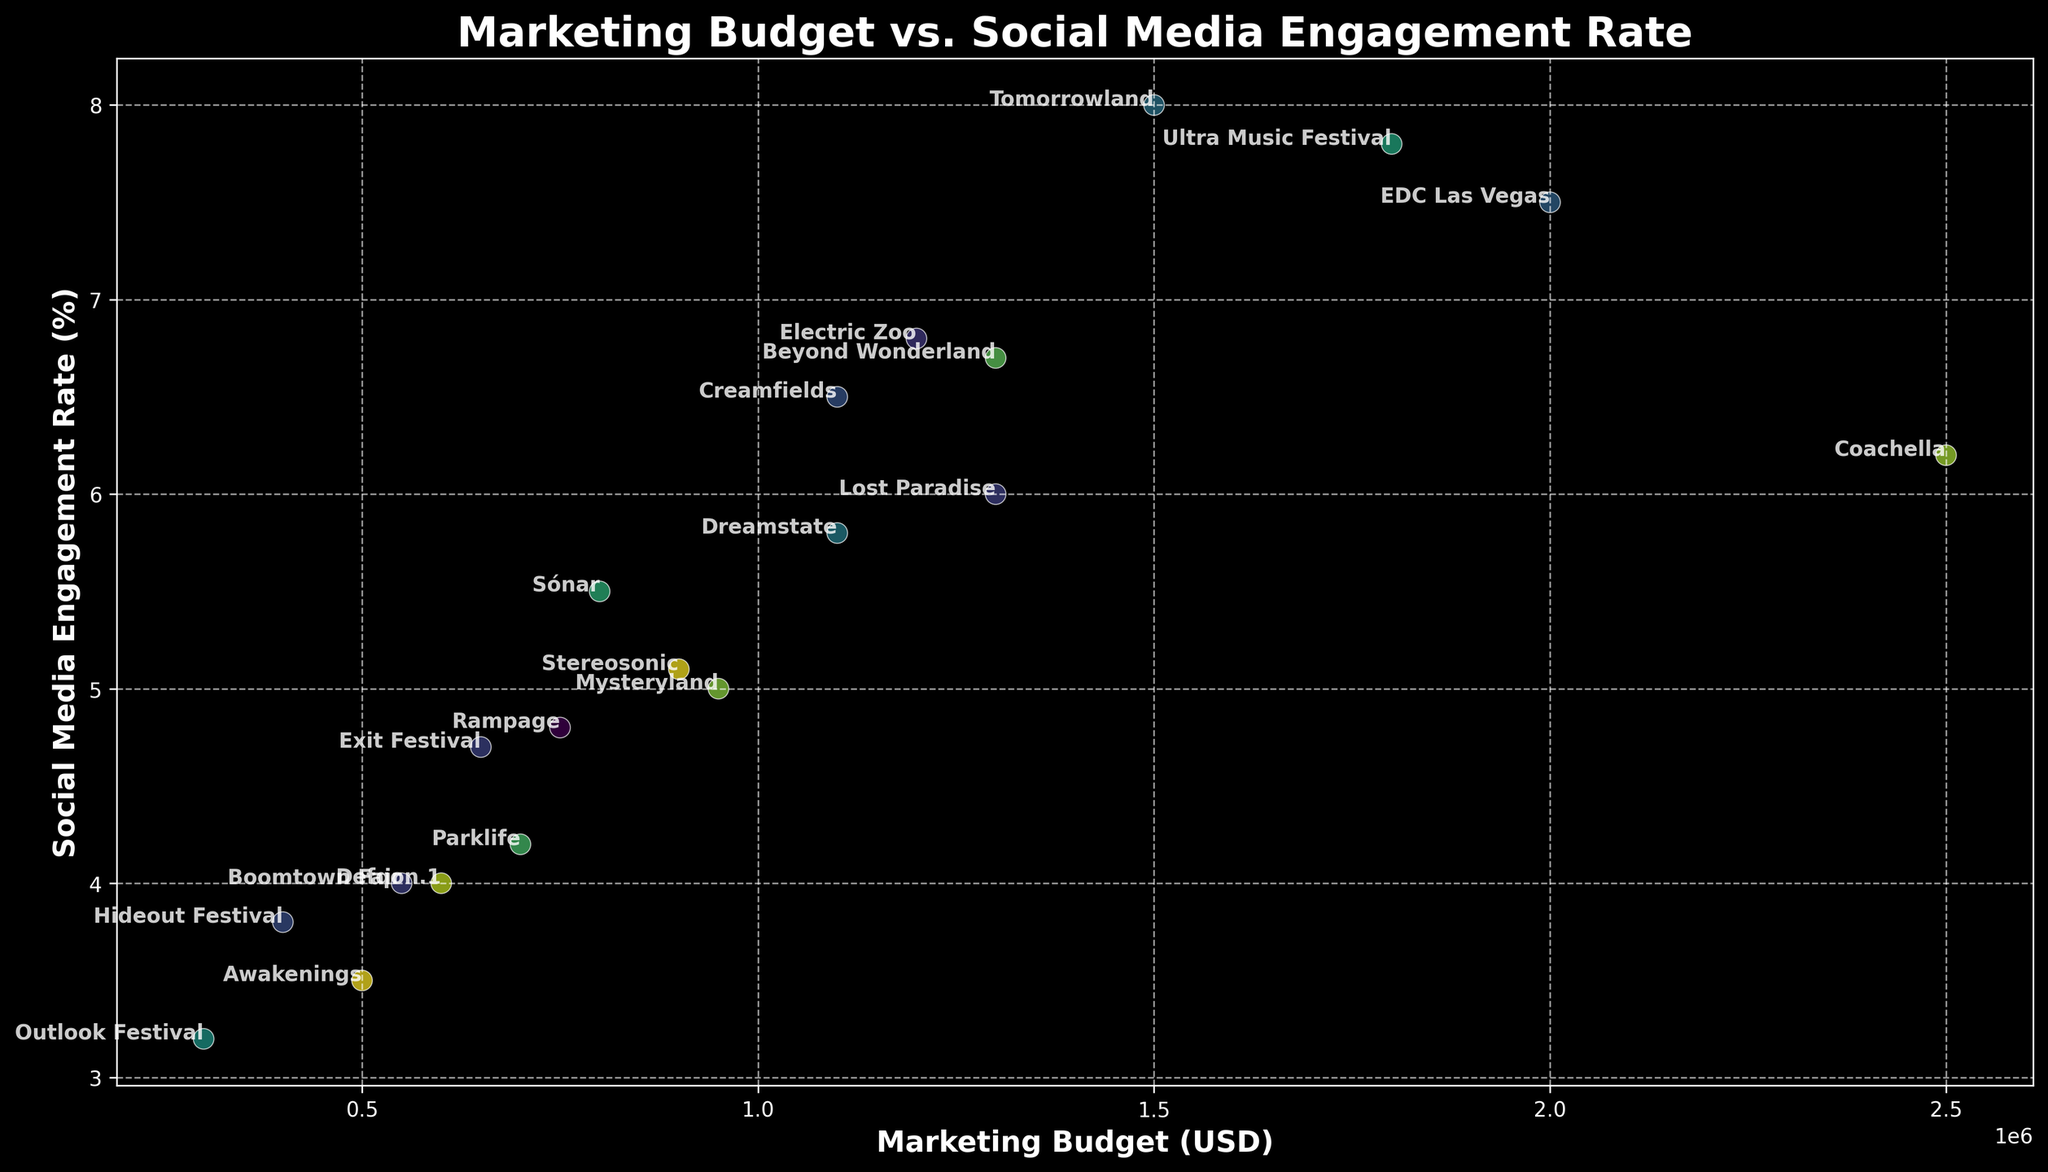What's the marketing budget of the festival with the highest engagement rate? First, identify the festival with the highest social media engagement rate, which is Tomorrowland at 8.0%. Then look for its marketing budget, which is $1,500,000.
Answer: $1,500,000 Which festival has the lowest social media engagement rate and what is its marketing budget? The festival with the lowest social media engagement rate is Outlook Festival at 3.2%. Its marketing budget is $300,000.
Answer: Outlook Festival, $300,000 What is the average social media engagement rate of festivals with a marketing budget above $1,000,000? Identify the festivals with marketing budgets above $1,000,000: EDC Las Vegas (7.5%), Tomorrowland (8.0%), Ultra Music Festival (7.8%), Coachella (6.2%), Electric Zoo (6.8%), Beyond Wonderland (6.7%), Lost Paradise (6.0%), Dreamstate (5.8%). Calculate their average engagement rate: (7.5 + 8.0 + 7.8 + 6.2 + 6.8 + 6.7 + 6.0 + 5.8) / 8 = 6.85%.
Answer: 6.85% How does Coachella's social media engagement rate compare to Dreamstate's? Look at the social media engagement rates for Coachella and Dreamstate. Coachella has a 6.2% rate, while Dreamstate has a 5.8% rate. Coachella's rate is higher.
Answer: Coachella's rate is higher Which festival is closest in color to Defqon.1 on the plot? Visually compare the color of Defqon.1 to other points. Possible candidates can be identified, and then the exact color match is determined. Assuming the closest color point is visually closest, which might vary slightly depending on the plot view.
Answer: [Provide accurate color comparison based on plot] What is the total marketing budget for all festivals with engagement rates above 5%? Identify festivals with engagement rates above 5%: EDC Las Vegas ($2,000,000), Tomorrowland ($1,500,000), Ultra Music Festival ($1,800,000), Coachella ($2,500,000), Creamfields ($1,100,000), Electric Zoo ($1,200,000), Beyond Wonderland ($1,300,000), Lost Paradise ($1,300,000), Dreamstate ($1,100,000), Stereosonic ($900,000). Sum their budgets: 2,000,000 + 1,500,000 + 1,800,000 + 2,500,000 + 1,100,000 + 1,200,000 + 1,300,000 + 1,300,000 + 1,100,000 + 900,000 = $14,700,000.
Answer: $14,700,000 Are there any festivals with the same engagement rate, and if so, which ones? Compare the engagement rates of all festivals visually or via list: Only Defqon.1 and Boomtown Fair both have a 4.0% engagement rate.
Answer: Defqon.1 and Boomtown Fair What is the difference in engagement rates between EDC Las Vegas and Parklife? EDC Las Vegas has an engagement rate of 7.5%, whereas Parklife has 4.2%. The difference is 7.5 - 4.2 = 3.3%.
Answer: 3.3% What is the median social media engagement rate for all festivals? List all engagement rates: [7.5, 8.0, 7.8, 6.2, 5.5, 4.0, 6.5, 5.0, 6.8, 3.5, 4.2, 4.7, 5.1, 6.7, 3.8, 4.0, 3.2, 4.8, 6.0, 5.8]. The median value is in the middle of this ordered list, which is 5.55% (average of the 10th and 11th entries: 5.55 = (5.1 + 6.0) / 2).
Answer: 5.55% Is there a clear correlation between marketing budget and social media engagement rates? Visually inspect the scatter plot to see if higher engagement rates consistently align with larger marketing budgets, or check if there is a random distribution.
Answer: There is no clear correlation 